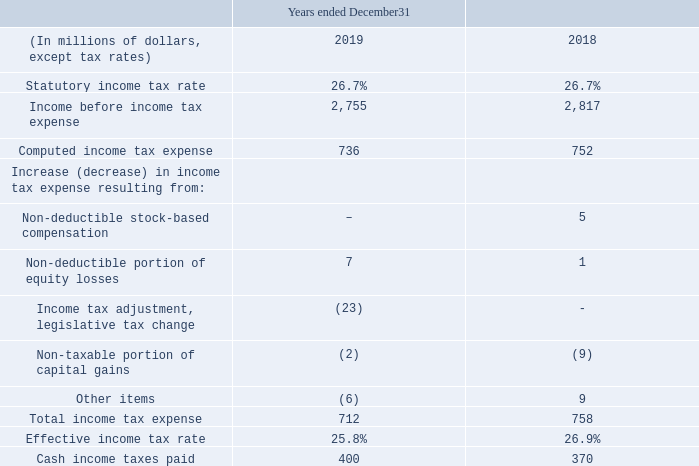INCOME TAX EXPENSE
Below is a summary of the difference between income tax expense computed by applying the statutory income tax rate to income before income tax expense and the actual income tax expense for the year.
Our effective income tax rate this year was 25.8% compared to 26.9% for 2018. The effective income tax rate for 2019 was lower than the statutory tax rate primarily as a result of a reduction to the Alberta corporate income tax rate over a four-year period.
Cash income taxes paid increased this year primarily as a result of the timing of installment payments.
What was the effective tax rate in 2019? 25.8%. What was the effective tax rate in 2018? 26.9%. What was the reason was decrease in effective tax rate from 2019 to 2018? Result of a reduction to the alberta corporate income tax rate over a four-year period. What was the increase / (decrease) in Income before income tax expense from 2019 to 2018?
Answer scale should be: million. 2,755 - 2,817
Answer: -62. What was the average Computed income tax expense?
Answer scale should be: million. (736 + 752) / 2
Answer: 744. What was the percentage increase / (decrease) in Total income tax expense from 2018 to 2019?
Answer scale should be: percent. 712 / 758 - 1
Answer: -6.07. 